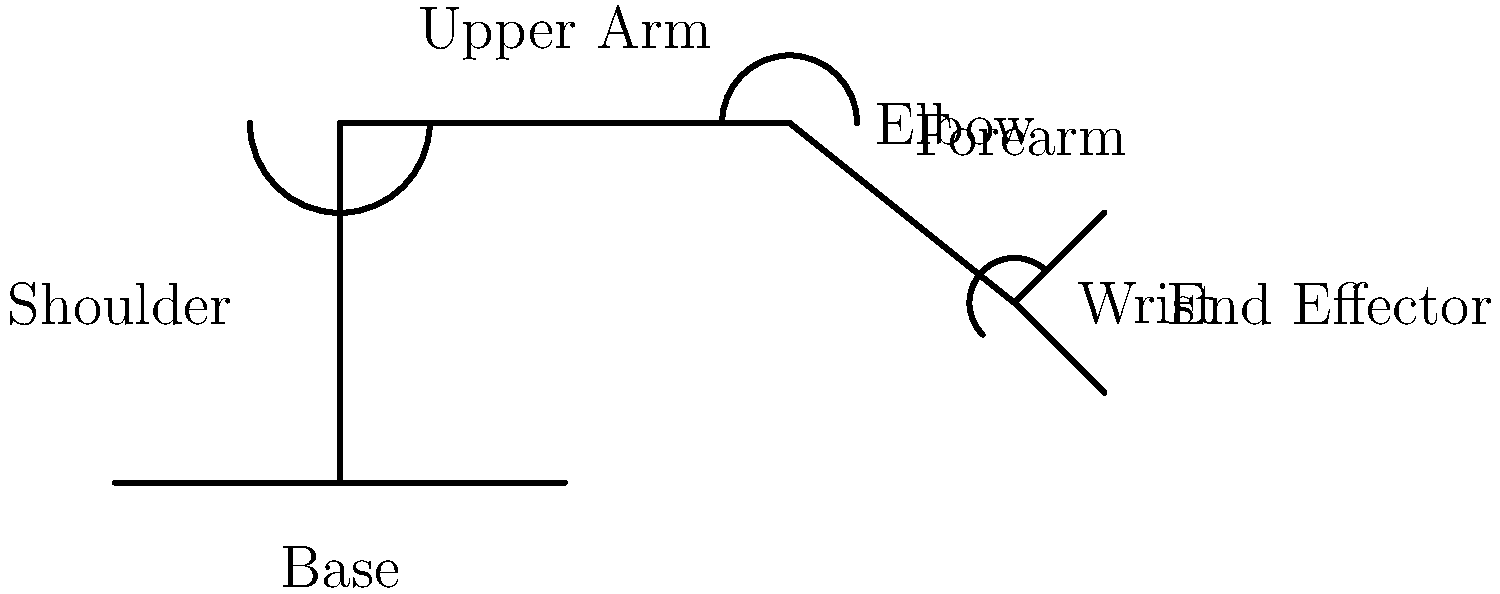Identify the component of a robotic arm that connects the upper arm to the forearm and allows for bending motion. To answer this question, let's break down the basic components of a robotic arm:

1. Base: The foundation of the robotic arm, typically fixed to a surface.
2. Shoulder: The joint connecting the base to the upper arm, allowing for rotational movement.
3. Upper Arm: The first major segment of the arm, extending from the shoulder.
4. Elbow: The joint connecting the upper arm to the forearm, enabling bending motion.
5. Forearm: The second major segment of the arm, extending from the elbow.
6. Wrist: The joint at the end of the forearm, providing additional degrees of freedom.
7. End Effector: The tool or gripper at the end of the arm, used to interact with objects.

The question asks about the component that connects the upper arm to the forearm and allows for bending motion. This description clearly matches the function of the elbow joint in a robotic arm.
Answer: Elbow 